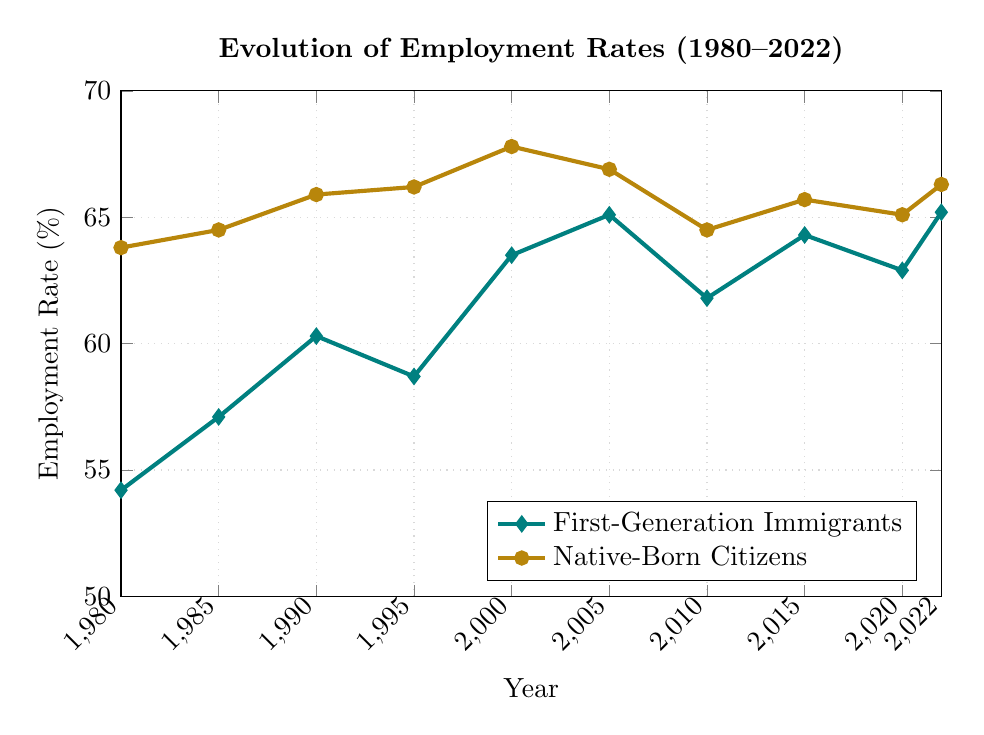What was the employment rate for first-generation immigrants in 2000? From the line that represents first-generation immigrants, find the point corresponding to the year 2000. The y-axis value at that point is the employment rate.
Answer: 63.5% In which year did the native-born citizens have the lowest employment rate? Look for the lowest point on the line representing native-born citizens and match it with the corresponding year on the x-axis.
Answer: 2010 By how much did the employment rate of first-generation immigrants increase from 1980 to 1985? Find the employment rates for first-generation immigrants in 1980 and 1985. Subtract the 1980 value from the 1985 value: 57.1 - 54.2.
Answer: 2.9% Between which consecutive years did first-generation immigrants see the largest increase in employment rate? Calculate the differences between consecutive years for first-generation immigrants and identify the maximum increase. The largest increase is between 2000 and 2005 (65.1 - 63.5 = 1.6).
Answer: 2000 and 2005 What is the average employment rate of native-born citizens across all the years shown? Sum all the employment rates for native-born citizens and divide by the number of data points: (63.8 + 64.5 + 65.9 + 66.2 + 67.8 + 66.9 + 64.5 + 65.7 + 65.1 + 66.3) / 10.
Answer: 65.67% Which group had a higher employment rate in 2015, and by how much? Compare the employment rates of first-generation immigrants and native-born citizens in 2015. Subtract the lower rate from the higher rate: 65.7 - 64.3.
Answer: Native-born citizens by 1.4% What was the employment rate difference between first-generation immigrants and native-born citizens in 2022? Subtract the employment rate of first-generation immigrants in 2022 from that of native-born citizens in 2022: 66.3 - 65.2.
Answer: 1.1% How did the employment rate for native-born citizens change from 2005 to 2010? Subtract the employment rate in 2005 from that in 2010: 64.5 - 66.9.
Answer: Decreased by 2.4% In which time period did both groups experience a decrease in employment rates? Observe the trends in employment rates over time to find periods where both lines slope downward. From 2005 to 2010, both groups experienced a decrease (65.1 to 61.8 for first-generation immigrants and 66.9 to 64.5 for native-born citizens).
Answer: 2005 to 2010 What is the trend in employment rates for both groups from 1980 to 2022? Analyze the overall direction of both lines from 1980 to 2022. Both lines show a general trend of increasing employment rates, with some fluctuations.
Answer: Increasing trend with fluctuations 